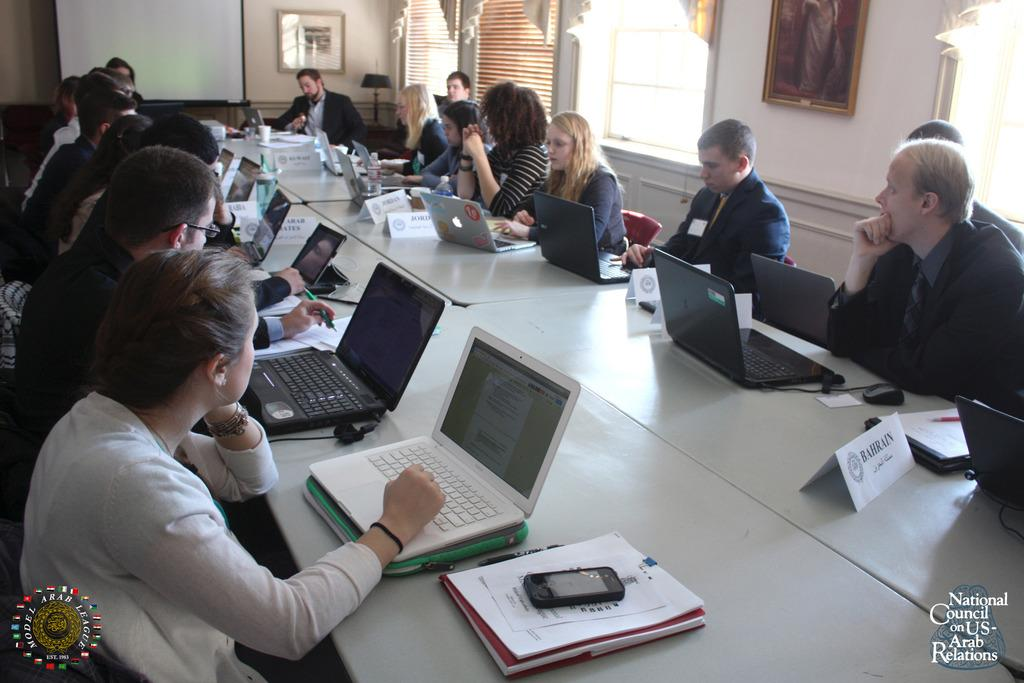<image>
Provide a brief description of the given image. A group of people attending the National Council on US-Arab Relations 